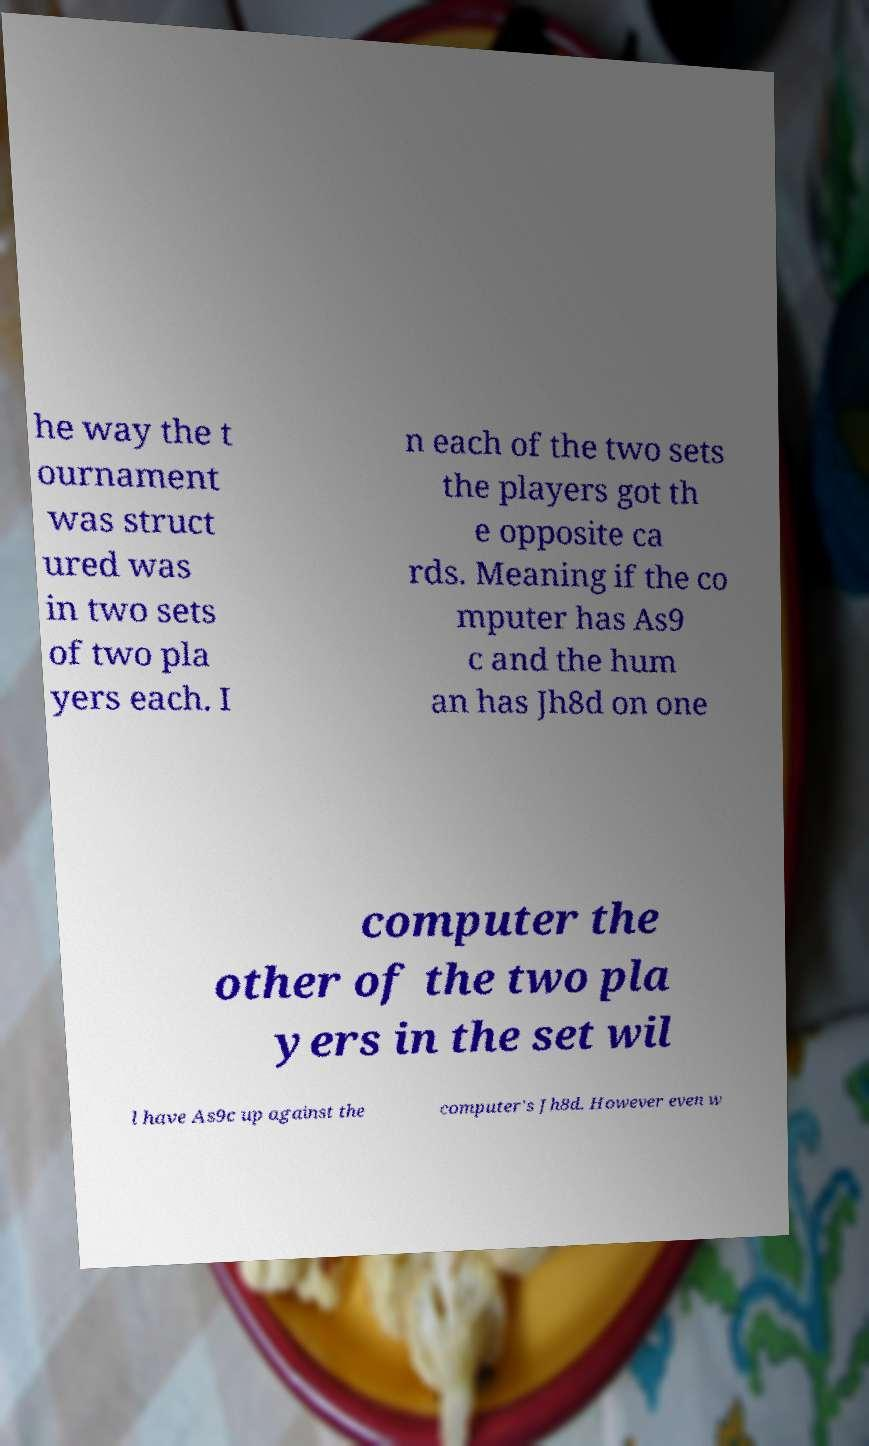Could you assist in decoding the text presented in this image and type it out clearly? he way the t ournament was struct ured was in two sets of two pla yers each. I n each of the two sets the players got th e opposite ca rds. Meaning if the co mputer has As9 c and the hum an has Jh8d on one computer the other of the two pla yers in the set wil l have As9c up against the computer's Jh8d. However even w 